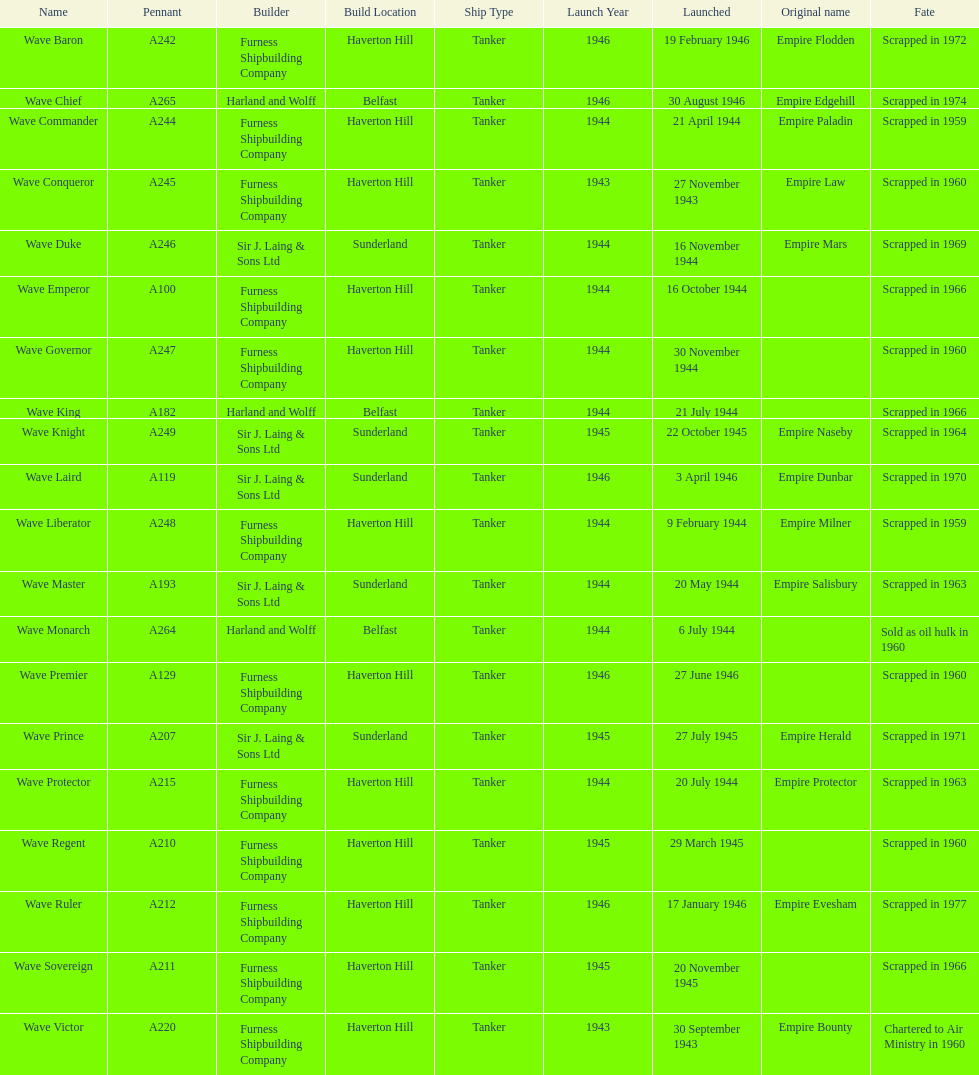How many boats were launched in the year 1944? 9. 